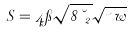Convert formula to latex. <formula><loc_0><loc_0><loc_500><loc_500>S = 4 \pi \sqrt { 8 \, \lambda _ { 2 } } \sqrt { n w }</formula> 